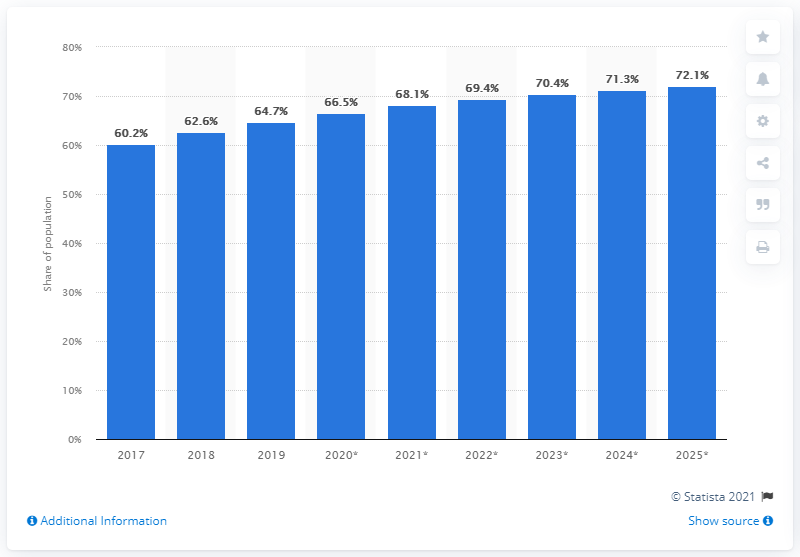Specify some key components in this picture. In 2019, the blue bar percentage value was 64.7%. The average of the first and last bars, such as those in 2017 and 2025, is 66.15. According to projections, Brazil's share of social media is expected to reach 72.1% by 2025. 